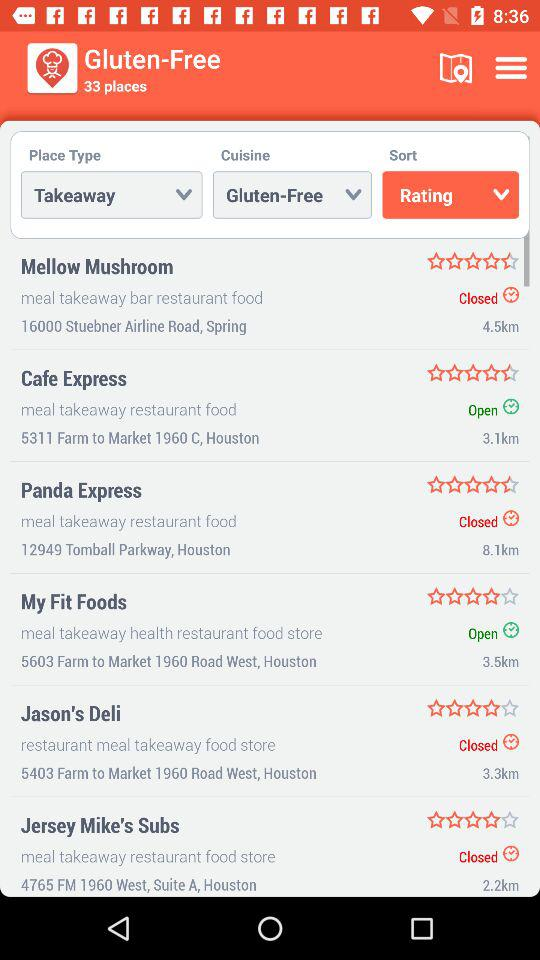What is the star rating of "My Fit Foods"? The rating is 4 stars. 